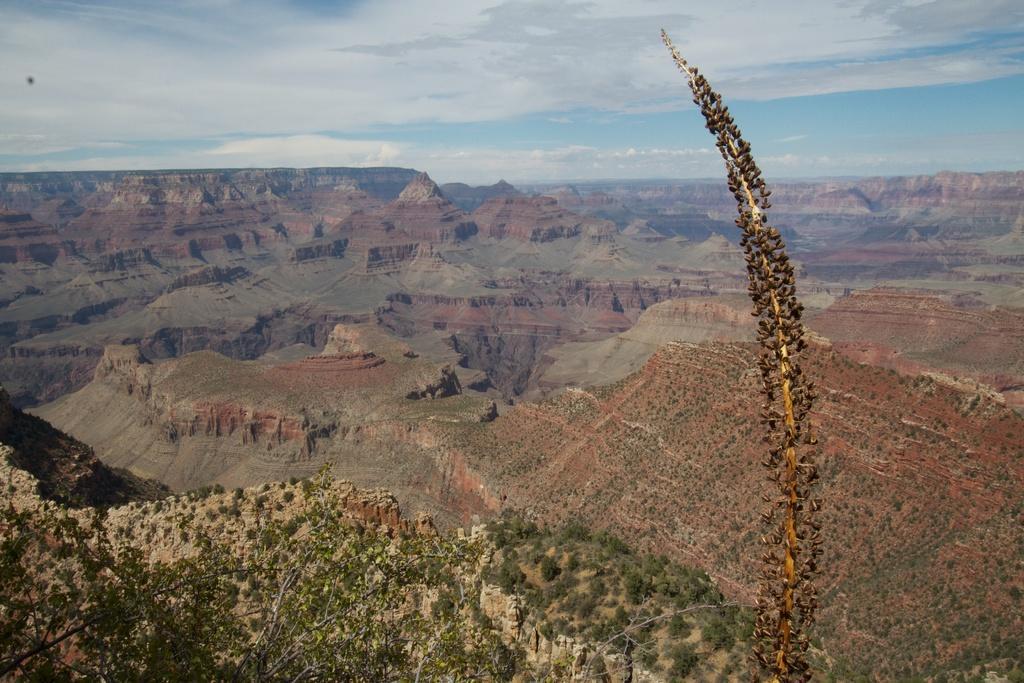Describe this image in one or two sentences. In the picture we can see some hills with grass and plants and from the Aerial view we can see some hills with grass and plants and in the background we can see a sky with clouds. 